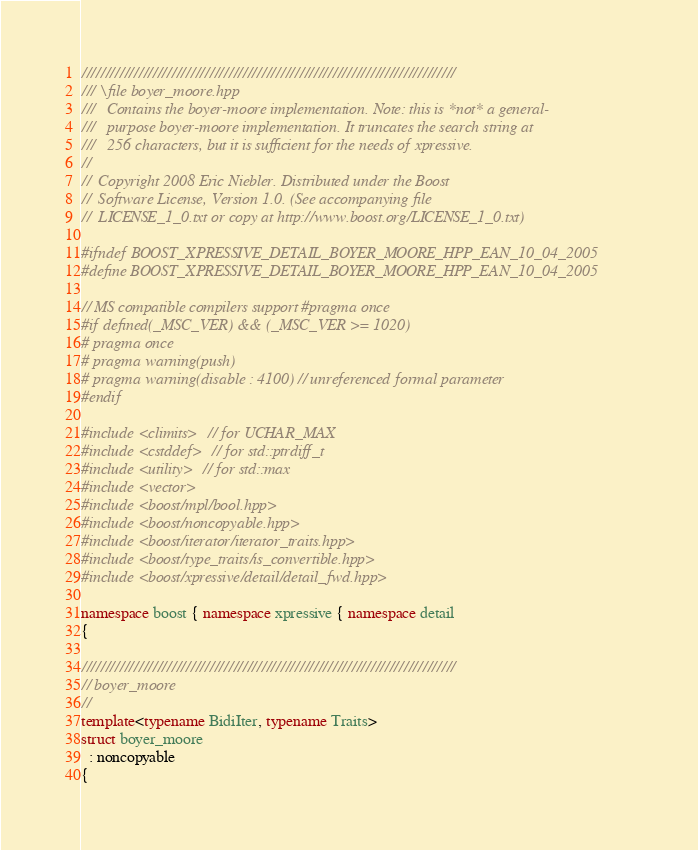<code> <loc_0><loc_0><loc_500><loc_500><_C++_>///////////////////////////////////////////////////////////////////////////////
/// \file boyer_moore.hpp
///   Contains the boyer-moore implementation. Note: this is *not* a general-
///   purpose boyer-moore implementation. It truncates the search string at
///   256 characters, but it is sufficient for the needs of xpressive.
//
//  Copyright 2008 Eric Niebler. Distributed under the Boost
//  Software License, Version 1.0. (See accompanying file
//  LICENSE_1_0.txt or copy at http://www.boost.org/LICENSE_1_0.txt)

#ifndef BOOST_XPRESSIVE_DETAIL_BOYER_MOORE_HPP_EAN_10_04_2005
#define BOOST_XPRESSIVE_DETAIL_BOYER_MOORE_HPP_EAN_10_04_2005

// MS compatible compilers support #pragma once
#if defined(_MSC_VER) && (_MSC_VER >= 1020)
# pragma once
# pragma warning(push)
# pragma warning(disable : 4100) // unreferenced formal parameter
#endif

#include <climits>  // for UCHAR_MAX
#include <cstddef>  // for std::ptrdiff_t
#include <utility>  // for std::max
#include <vector>
#include <boost/mpl/bool.hpp>
#include <boost/noncopyable.hpp>
#include <boost/iterator/iterator_traits.hpp>
#include <boost/type_traits/is_convertible.hpp>
#include <boost/xpressive/detail/detail_fwd.hpp>

namespace boost { namespace xpressive { namespace detail
{

///////////////////////////////////////////////////////////////////////////////
// boyer_moore
//
template<typename BidiIter, typename Traits>
struct boyer_moore
  : noncopyable
{</code> 